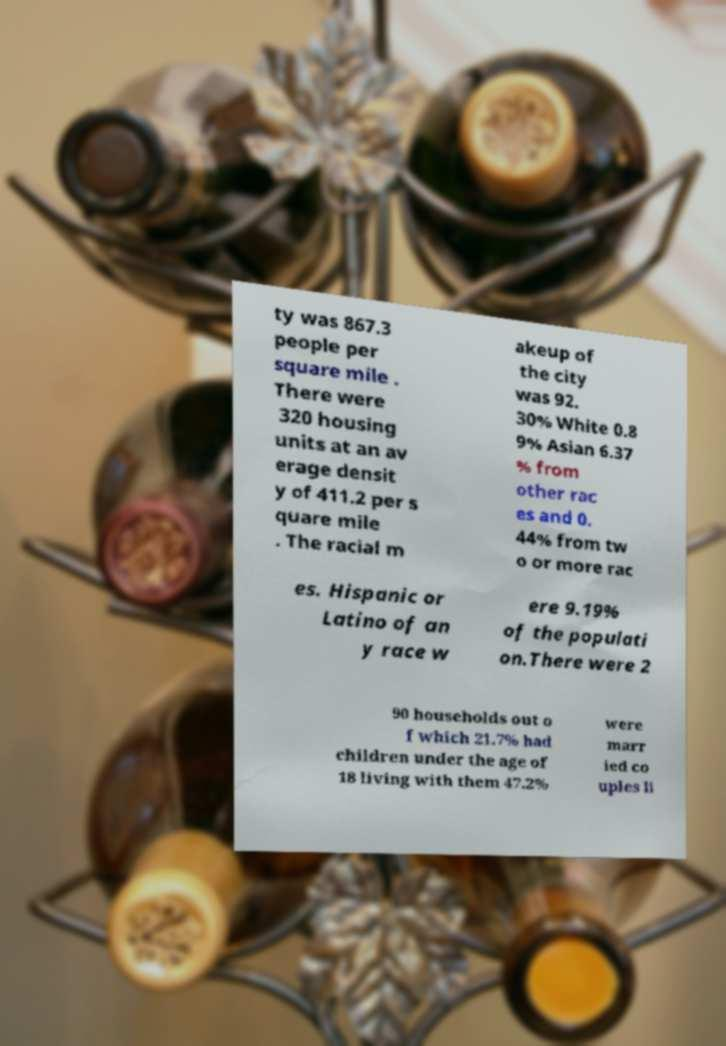Could you assist in decoding the text presented in this image and type it out clearly? ty was 867.3 people per square mile . There were 320 housing units at an av erage densit y of 411.2 per s quare mile . The racial m akeup of the city was 92. 30% White 0.8 9% Asian 6.37 % from other rac es and 0. 44% from tw o or more rac es. Hispanic or Latino of an y race w ere 9.19% of the populati on.There were 2 90 households out o f which 21.7% had children under the age of 18 living with them 47.2% were marr ied co uples li 